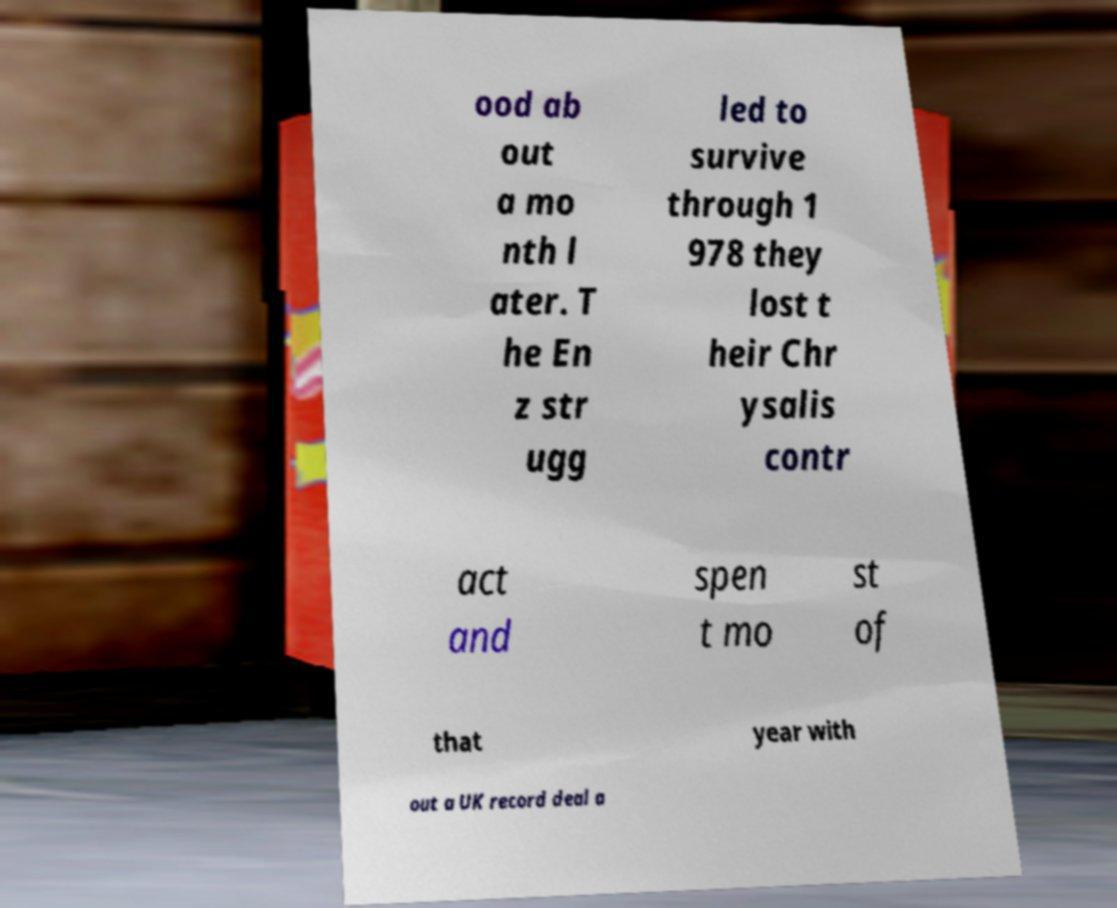What messages or text are displayed in this image? I need them in a readable, typed format. ood ab out a mo nth l ater. T he En z str ugg led to survive through 1 978 they lost t heir Chr ysalis contr act and spen t mo st of that year with out a UK record deal a 